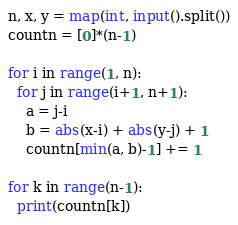<code> <loc_0><loc_0><loc_500><loc_500><_Python_>n, x, y = map(int, input().split())
countn = [0]*(n-1)

for i in range(1, n):
  for j in range(i+1, n+1):
    a = j-i
    b = abs(x-i) + abs(y-j) + 1
    countn[min(a, b)-1] += 1
    
for k in range(n-1):
  print(countn[k])
</code> 